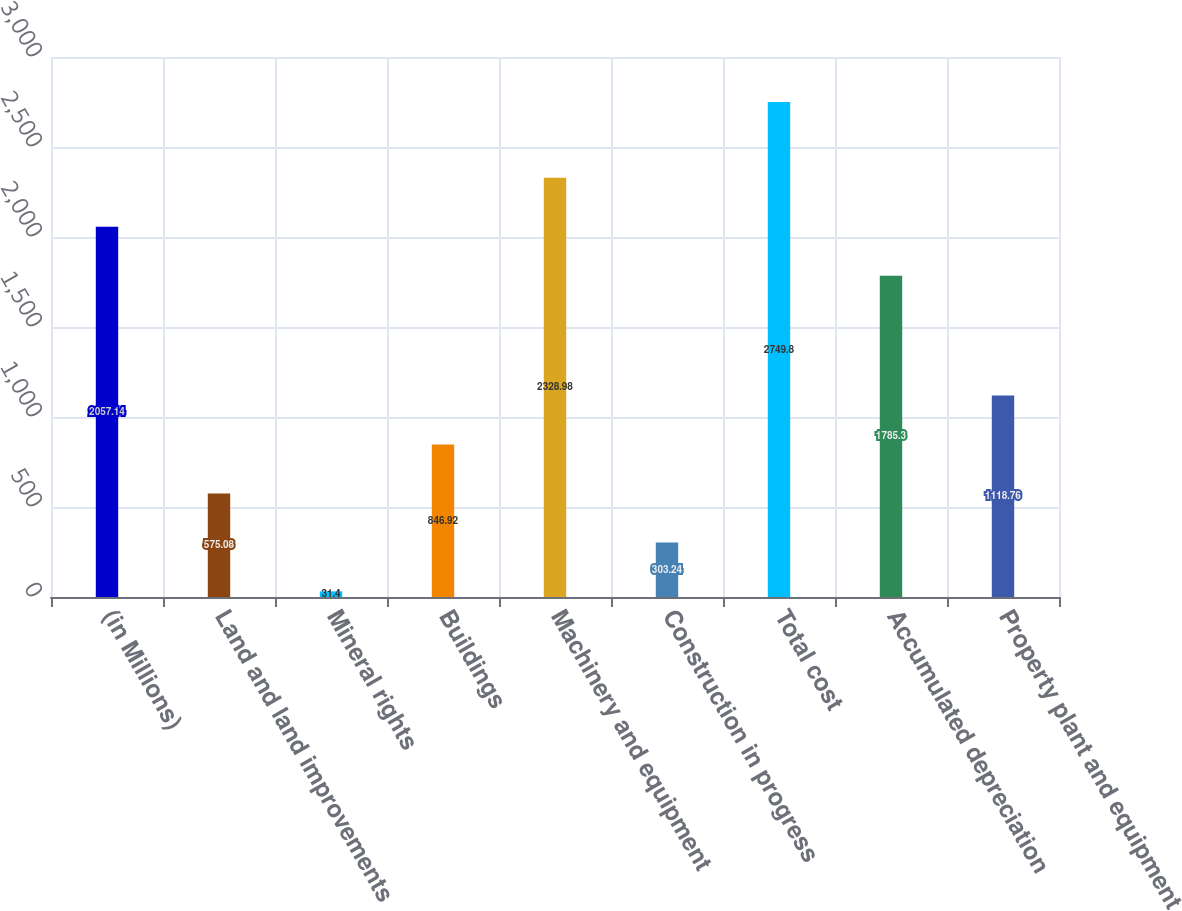Convert chart to OTSL. <chart><loc_0><loc_0><loc_500><loc_500><bar_chart><fcel>(in Millions)<fcel>Land and land improvements<fcel>Mineral rights<fcel>Buildings<fcel>Machinery and equipment<fcel>Construction in progress<fcel>Total cost<fcel>Accumulated depreciation<fcel>Property plant and equipment<nl><fcel>2057.14<fcel>575.08<fcel>31.4<fcel>846.92<fcel>2328.98<fcel>303.24<fcel>2749.8<fcel>1785.3<fcel>1118.76<nl></chart> 